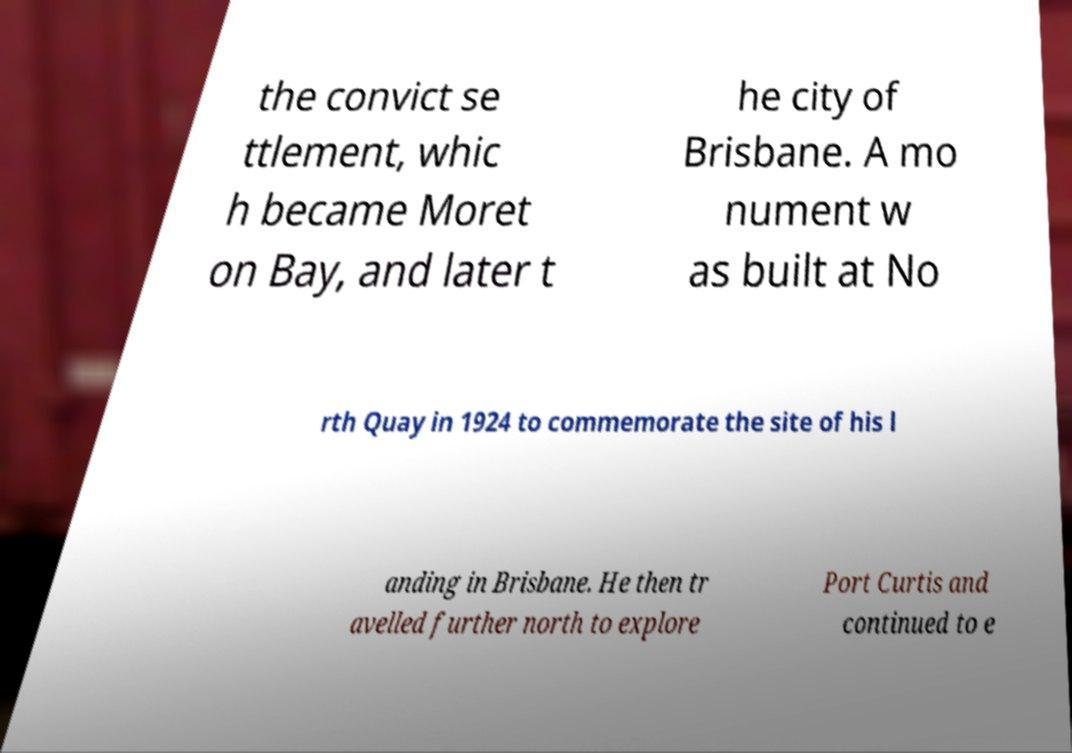I need the written content from this picture converted into text. Can you do that? the convict se ttlement, whic h became Moret on Bay, and later t he city of Brisbane. A mo nument w as built at No rth Quay in 1924 to commemorate the site of his l anding in Brisbane. He then tr avelled further north to explore Port Curtis and continued to e 